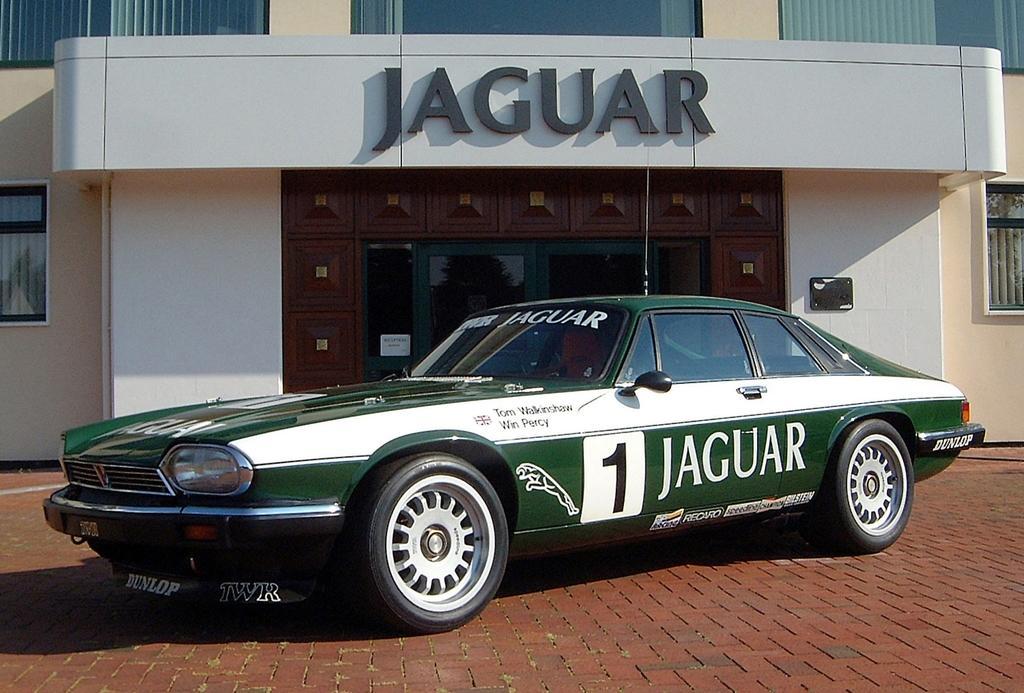Could you give a brief overview of what you see in this image? In this picture I can see a car in the middle, in the background there are glass doors and a board, I can see the building. 